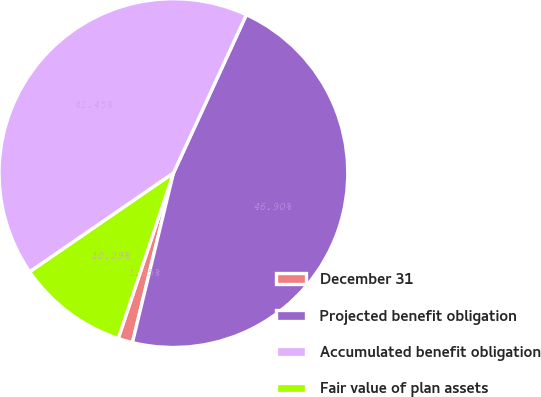Convert chart to OTSL. <chart><loc_0><loc_0><loc_500><loc_500><pie_chart><fcel>December 31<fcel>Projected benefit obligation<fcel>Accumulated benefit obligation<fcel>Fair value of plan assets<nl><fcel>1.35%<fcel>46.9%<fcel>41.45%<fcel>10.29%<nl></chart> 